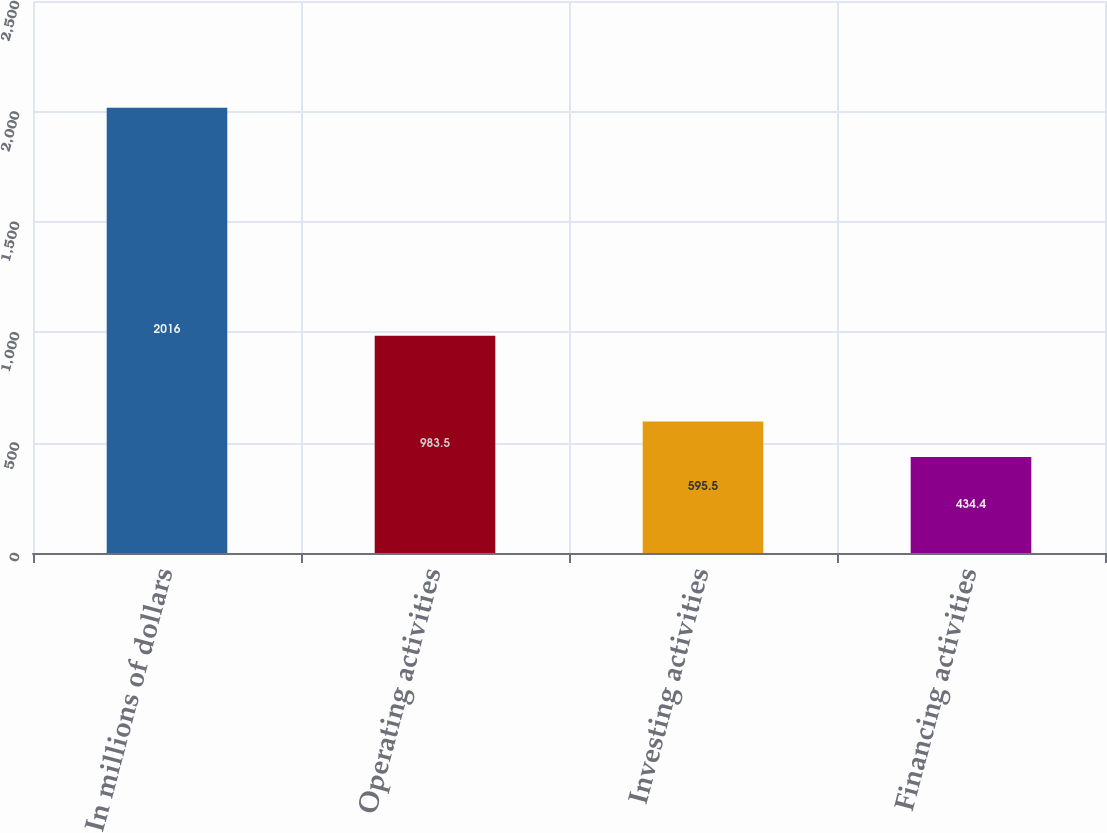Convert chart. <chart><loc_0><loc_0><loc_500><loc_500><bar_chart><fcel>In millions of dollars<fcel>Operating activities<fcel>Investing activities<fcel>Financing activities<nl><fcel>2016<fcel>983.5<fcel>595.5<fcel>434.4<nl></chart> 